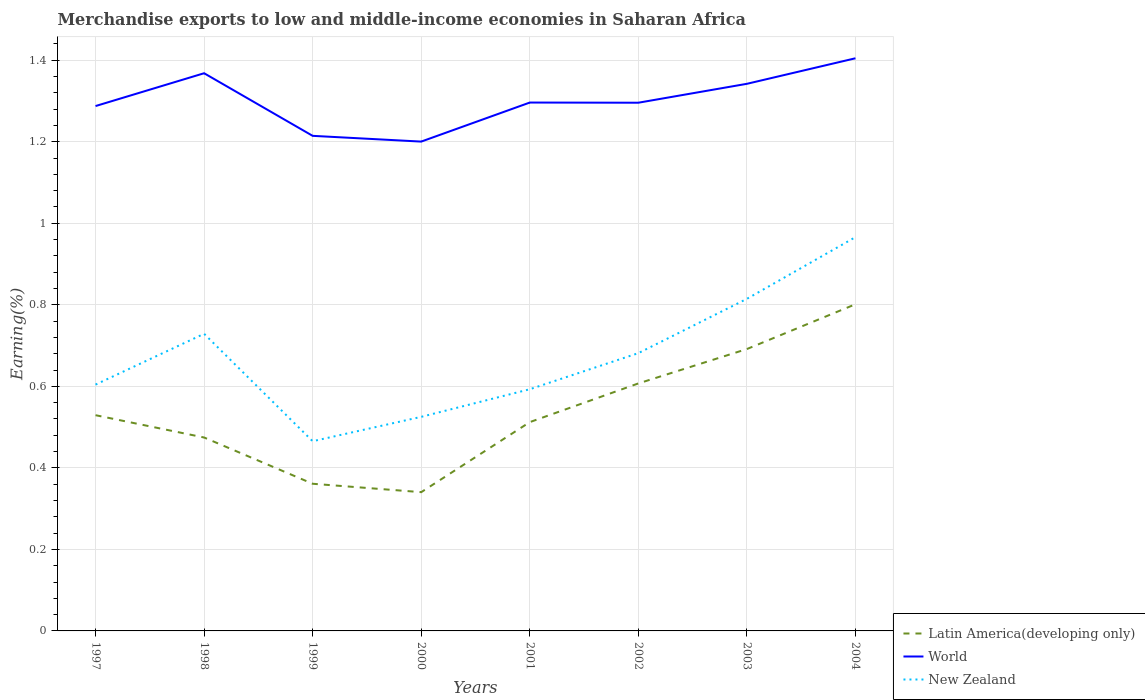How many different coloured lines are there?
Offer a very short reply. 3. Is the number of lines equal to the number of legend labels?
Provide a succinct answer. Yes. Across all years, what is the maximum percentage of amount earned from merchandise exports in New Zealand?
Your answer should be very brief. 0.47. What is the total percentage of amount earned from merchandise exports in Latin America(developing only) in the graph?
Offer a terse response. -0.08. What is the difference between the highest and the second highest percentage of amount earned from merchandise exports in Latin America(developing only)?
Keep it short and to the point. 0.46. What is the difference between two consecutive major ticks on the Y-axis?
Your answer should be compact. 0.2. Are the values on the major ticks of Y-axis written in scientific E-notation?
Ensure brevity in your answer.  No. Does the graph contain grids?
Your answer should be compact. Yes. Where does the legend appear in the graph?
Keep it short and to the point. Bottom right. What is the title of the graph?
Make the answer very short. Merchandise exports to low and middle-income economies in Saharan Africa. Does "Tonga" appear as one of the legend labels in the graph?
Your answer should be compact. No. What is the label or title of the Y-axis?
Offer a terse response. Earning(%). What is the Earning(%) of Latin America(developing only) in 1997?
Give a very brief answer. 0.53. What is the Earning(%) in World in 1997?
Give a very brief answer. 1.29. What is the Earning(%) in New Zealand in 1997?
Provide a succinct answer. 0.6. What is the Earning(%) in Latin America(developing only) in 1998?
Your answer should be very brief. 0.47. What is the Earning(%) in World in 1998?
Provide a succinct answer. 1.37. What is the Earning(%) of New Zealand in 1998?
Keep it short and to the point. 0.73. What is the Earning(%) in Latin America(developing only) in 1999?
Offer a very short reply. 0.36. What is the Earning(%) of World in 1999?
Your response must be concise. 1.21. What is the Earning(%) of New Zealand in 1999?
Make the answer very short. 0.47. What is the Earning(%) in Latin America(developing only) in 2000?
Your answer should be very brief. 0.34. What is the Earning(%) in World in 2000?
Give a very brief answer. 1.2. What is the Earning(%) in New Zealand in 2000?
Make the answer very short. 0.53. What is the Earning(%) of Latin America(developing only) in 2001?
Give a very brief answer. 0.51. What is the Earning(%) of World in 2001?
Your answer should be compact. 1.3. What is the Earning(%) in New Zealand in 2001?
Your answer should be very brief. 0.59. What is the Earning(%) of Latin America(developing only) in 2002?
Your response must be concise. 0.61. What is the Earning(%) in World in 2002?
Your response must be concise. 1.3. What is the Earning(%) in New Zealand in 2002?
Your answer should be compact. 0.68. What is the Earning(%) in Latin America(developing only) in 2003?
Keep it short and to the point. 0.69. What is the Earning(%) in World in 2003?
Your answer should be very brief. 1.34. What is the Earning(%) in New Zealand in 2003?
Offer a terse response. 0.81. What is the Earning(%) of Latin America(developing only) in 2004?
Provide a short and direct response. 0.8. What is the Earning(%) in World in 2004?
Provide a succinct answer. 1.4. What is the Earning(%) in New Zealand in 2004?
Provide a short and direct response. 0.97. Across all years, what is the maximum Earning(%) of Latin America(developing only)?
Your answer should be very brief. 0.8. Across all years, what is the maximum Earning(%) of World?
Offer a terse response. 1.4. Across all years, what is the maximum Earning(%) of New Zealand?
Make the answer very short. 0.97. Across all years, what is the minimum Earning(%) in Latin America(developing only)?
Give a very brief answer. 0.34. Across all years, what is the minimum Earning(%) in World?
Ensure brevity in your answer.  1.2. Across all years, what is the minimum Earning(%) in New Zealand?
Provide a short and direct response. 0.47. What is the total Earning(%) of Latin America(developing only) in the graph?
Offer a very short reply. 4.32. What is the total Earning(%) of World in the graph?
Provide a short and direct response. 10.41. What is the total Earning(%) of New Zealand in the graph?
Your answer should be compact. 5.38. What is the difference between the Earning(%) in Latin America(developing only) in 1997 and that in 1998?
Provide a succinct answer. 0.05. What is the difference between the Earning(%) of World in 1997 and that in 1998?
Provide a succinct answer. -0.08. What is the difference between the Earning(%) in New Zealand in 1997 and that in 1998?
Give a very brief answer. -0.12. What is the difference between the Earning(%) of Latin America(developing only) in 1997 and that in 1999?
Your response must be concise. 0.17. What is the difference between the Earning(%) in World in 1997 and that in 1999?
Ensure brevity in your answer.  0.07. What is the difference between the Earning(%) in New Zealand in 1997 and that in 1999?
Provide a succinct answer. 0.14. What is the difference between the Earning(%) in Latin America(developing only) in 1997 and that in 2000?
Keep it short and to the point. 0.19. What is the difference between the Earning(%) of World in 1997 and that in 2000?
Offer a terse response. 0.09. What is the difference between the Earning(%) in New Zealand in 1997 and that in 2000?
Offer a terse response. 0.08. What is the difference between the Earning(%) of Latin America(developing only) in 1997 and that in 2001?
Your response must be concise. 0.02. What is the difference between the Earning(%) in World in 1997 and that in 2001?
Offer a very short reply. -0.01. What is the difference between the Earning(%) in New Zealand in 1997 and that in 2001?
Provide a succinct answer. 0.01. What is the difference between the Earning(%) of Latin America(developing only) in 1997 and that in 2002?
Ensure brevity in your answer.  -0.08. What is the difference between the Earning(%) of World in 1997 and that in 2002?
Your response must be concise. -0.01. What is the difference between the Earning(%) in New Zealand in 1997 and that in 2002?
Offer a very short reply. -0.08. What is the difference between the Earning(%) of Latin America(developing only) in 1997 and that in 2003?
Offer a terse response. -0.16. What is the difference between the Earning(%) of World in 1997 and that in 2003?
Give a very brief answer. -0.05. What is the difference between the Earning(%) of New Zealand in 1997 and that in 2003?
Make the answer very short. -0.21. What is the difference between the Earning(%) in Latin America(developing only) in 1997 and that in 2004?
Your response must be concise. -0.27. What is the difference between the Earning(%) in World in 1997 and that in 2004?
Your answer should be very brief. -0.12. What is the difference between the Earning(%) of New Zealand in 1997 and that in 2004?
Provide a succinct answer. -0.36. What is the difference between the Earning(%) in Latin America(developing only) in 1998 and that in 1999?
Ensure brevity in your answer.  0.11. What is the difference between the Earning(%) in World in 1998 and that in 1999?
Provide a short and direct response. 0.15. What is the difference between the Earning(%) of New Zealand in 1998 and that in 1999?
Keep it short and to the point. 0.26. What is the difference between the Earning(%) of Latin America(developing only) in 1998 and that in 2000?
Your response must be concise. 0.13. What is the difference between the Earning(%) of World in 1998 and that in 2000?
Provide a succinct answer. 0.17. What is the difference between the Earning(%) of New Zealand in 1998 and that in 2000?
Provide a short and direct response. 0.2. What is the difference between the Earning(%) of Latin America(developing only) in 1998 and that in 2001?
Offer a very short reply. -0.04. What is the difference between the Earning(%) in World in 1998 and that in 2001?
Ensure brevity in your answer.  0.07. What is the difference between the Earning(%) of New Zealand in 1998 and that in 2001?
Your answer should be compact. 0.14. What is the difference between the Earning(%) in Latin America(developing only) in 1998 and that in 2002?
Offer a very short reply. -0.13. What is the difference between the Earning(%) in World in 1998 and that in 2002?
Give a very brief answer. 0.07. What is the difference between the Earning(%) in New Zealand in 1998 and that in 2002?
Make the answer very short. 0.05. What is the difference between the Earning(%) of Latin America(developing only) in 1998 and that in 2003?
Offer a terse response. -0.22. What is the difference between the Earning(%) in World in 1998 and that in 2003?
Keep it short and to the point. 0.03. What is the difference between the Earning(%) in New Zealand in 1998 and that in 2003?
Provide a short and direct response. -0.09. What is the difference between the Earning(%) of Latin America(developing only) in 1998 and that in 2004?
Offer a terse response. -0.33. What is the difference between the Earning(%) in World in 1998 and that in 2004?
Your answer should be compact. -0.04. What is the difference between the Earning(%) of New Zealand in 1998 and that in 2004?
Your answer should be very brief. -0.24. What is the difference between the Earning(%) in Latin America(developing only) in 1999 and that in 2000?
Your response must be concise. 0.02. What is the difference between the Earning(%) in World in 1999 and that in 2000?
Your answer should be compact. 0.01. What is the difference between the Earning(%) of New Zealand in 1999 and that in 2000?
Ensure brevity in your answer.  -0.06. What is the difference between the Earning(%) of Latin America(developing only) in 1999 and that in 2001?
Provide a succinct answer. -0.15. What is the difference between the Earning(%) in World in 1999 and that in 2001?
Your answer should be very brief. -0.08. What is the difference between the Earning(%) in New Zealand in 1999 and that in 2001?
Keep it short and to the point. -0.13. What is the difference between the Earning(%) of Latin America(developing only) in 1999 and that in 2002?
Your answer should be very brief. -0.25. What is the difference between the Earning(%) of World in 1999 and that in 2002?
Ensure brevity in your answer.  -0.08. What is the difference between the Earning(%) in New Zealand in 1999 and that in 2002?
Keep it short and to the point. -0.22. What is the difference between the Earning(%) in Latin America(developing only) in 1999 and that in 2003?
Give a very brief answer. -0.33. What is the difference between the Earning(%) of World in 1999 and that in 2003?
Your answer should be very brief. -0.13. What is the difference between the Earning(%) of New Zealand in 1999 and that in 2003?
Give a very brief answer. -0.35. What is the difference between the Earning(%) in Latin America(developing only) in 1999 and that in 2004?
Ensure brevity in your answer.  -0.44. What is the difference between the Earning(%) in World in 1999 and that in 2004?
Your answer should be compact. -0.19. What is the difference between the Earning(%) in New Zealand in 1999 and that in 2004?
Your answer should be compact. -0.5. What is the difference between the Earning(%) in Latin America(developing only) in 2000 and that in 2001?
Give a very brief answer. -0.17. What is the difference between the Earning(%) in World in 2000 and that in 2001?
Your response must be concise. -0.1. What is the difference between the Earning(%) of New Zealand in 2000 and that in 2001?
Provide a short and direct response. -0.07. What is the difference between the Earning(%) in Latin America(developing only) in 2000 and that in 2002?
Your answer should be compact. -0.27. What is the difference between the Earning(%) of World in 2000 and that in 2002?
Provide a succinct answer. -0.1. What is the difference between the Earning(%) of New Zealand in 2000 and that in 2002?
Offer a terse response. -0.16. What is the difference between the Earning(%) in Latin America(developing only) in 2000 and that in 2003?
Make the answer very short. -0.35. What is the difference between the Earning(%) of World in 2000 and that in 2003?
Offer a very short reply. -0.14. What is the difference between the Earning(%) in New Zealand in 2000 and that in 2003?
Make the answer very short. -0.29. What is the difference between the Earning(%) in Latin America(developing only) in 2000 and that in 2004?
Ensure brevity in your answer.  -0.46. What is the difference between the Earning(%) in World in 2000 and that in 2004?
Your response must be concise. -0.2. What is the difference between the Earning(%) in New Zealand in 2000 and that in 2004?
Your answer should be compact. -0.44. What is the difference between the Earning(%) in Latin America(developing only) in 2001 and that in 2002?
Make the answer very short. -0.09. What is the difference between the Earning(%) in New Zealand in 2001 and that in 2002?
Offer a terse response. -0.09. What is the difference between the Earning(%) of Latin America(developing only) in 2001 and that in 2003?
Your response must be concise. -0.18. What is the difference between the Earning(%) of World in 2001 and that in 2003?
Your answer should be very brief. -0.05. What is the difference between the Earning(%) in New Zealand in 2001 and that in 2003?
Keep it short and to the point. -0.22. What is the difference between the Earning(%) of Latin America(developing only) in 2001 and that in 2004?
Make the answer very short. -0.29. What is the difference between the Earning(%) of World in 2001 and that in 2004?
Your answer should be compact. -0.11. What is the difference between the Earning(%) of New Zealand in 2001 and that in 2004?
Provide a short and direct response. -0.37. What is the difference between the Earning(%) in Latin America(developing only) in 2002 and that in 2003?
Give a very brief answer. -0.08. What is the difference between the Earning(%) in World in 2002 and that in 2003?
Give a very brief answer. -0.05. What is the difference between the Earning(%) in New Zealand in 2002 and that in 2003?
Your answer should be compact. -0.13. What is the difference between the Earning(%) in Latin America(developing only) in 2002 and that in 2004?
Ensure brevity in your answer.  -0.19. What is the difference between the Earning(%) in World in 2002 and that in 2004?
Ensure brevity in your answer.  -0.11. What is the difference between the Earning(%) of New Zealand in 2002 and that in 2004?
Ensure brevity in your answer.  -0.28. What is the difference between the Earning(%) of Latin America(developing only) in 2003 and that in 2004?
Ensure brevity in your answer.  -0.11. What is the difference between the Earning(%) of World in 2003 and that in 2004?
Keep it short and to the point. -0.06. What is the difference between the Earning(%) in New Zealand in 2003 and that in 2004?
Offer a very short reply. -0.15. What is the difference between the Earning(%) in Latin America(developing only) in 1997 and the Earning(%) in World in 1998?
Ensure brevity in your answer.  -0.84. What is the difference between the Earning(%) of Latin America(developing only) in 1997 and the Earning(%) of New Zealand in 1998?
Ensure brevity in your answer.  -0.2. What is the difference between the Earning(%) of World in 1997 and the Earning(%) of New Zealand in 1998?
Your answer should be compact. 0.56. What is the difference between the Earning(%) of Latin America(developing only) in 1997 and the Earning(%) of World in 1999?
Give a very brief answer. -0.69. What is the difference between the Earning(%) in Latin America(developing only) in 1997 and the Earning(%) in New Zealand in 1999?
Ensure brevity in your answer.  0.06. What is the difference between the Earning(%) of World in 1997 and the Earning(%) of New Zealand in 1999?
Your answer should be very brief. 0.82. What is the difference between the Earning(%) in Latin America(developing only) in 1997 and the Earning(%) in World in 2000?
Offer a terse response. -0.67. What is the difference between the Earning(%) of Latin America(developing only) in 1997 and the Earning(%) of New Zealand in 2000?
Provide a succinct answer. 0. What is the difference between the Earning(%) of World in 1997 and the Earning(%) of New Zealand in 2000?
Your response must be concise. 0.76. What is the difference between the Earning(%) in Latin America(developing only) in 1997 and the Earning(%) in World in 2001?
Your answer should be compact. -0.77. What is the difference between the Earning(%) of Latin America(developing only) in 1997 and the Earning(%) of New Zealand in 2001?
Your response must be concise. -0.06. What is the difference between the Earning(%) of World in 1997 and the Earning(%) of New Zealand in 2001?
Provide a succinct answer. 0.69. What is the difference between the Earning(%) in Latin America(developing only) in 1997 and the Earning(%) in World in 2002?
Provide a short and direct response. -0.77. What is the difference between the Earning(%) in Latin America(developing only) in 1997 and the Earning(%) in New Zealand in 2002?
Your answer should be compact. -0.15. What is the difference between the Earning(%) in World in 1997 and the Earning(%) in New Zealand in 2002?
Offer a terse response. 0.61. What is the difference between the Earning(%) of Latin America(developing only) in 1997 and the Earning(%) of World in 2003?
Your response must be concise. -0.81. What is the difference between the Earning(%) in Latin America(developing only) in 1997 and the Earning(%) in New Zealand in 2003?
Provide a short and direct response. -0.29. What is the difference between the Earning(%) of World in 1997 and the Earning(%) of New Zealand in 2003?
Give a very brief answer. 0.47. What is the difference between the Earning(%) of Latin America(developing only) in 1997 and the Earning(%) of World in 2004?
Keep it short and to the point. -0.88. What is the difference between the Earning(%) in Latin America(developing only) in 1997 and the Earning(%) in New Zealand in 2004?
Offer a terse response. -0.44. What is the difference between the Earning(%) of World in 1997 and the Earning(%) of New Zealand in 2004?
Your answer should be compact. 0.32. What is the difference between the Earning(%) in Latin America(developing only) in 1998 and the Earning(%) in World in 1999?
Offer a very short reply. -0.74. What is the difference between the Earning(%) of Latin America(developing only) in 1998 and the Earning(%) of New Zealand in 1999?
Provide a short and direct response. 0.01. What is the difference between the Earning(%) of World in 1998 and the Earning(%) of New Zealand in 1999?
Provide a short and direct response. 0.9. What is the difference between the Earning(%) of Latin America(developing only) in 1998 and the Earning(%) of World in 2000?
Keep it short and to the point. -0.73. What is the difference between the Earning(%) in Latin America(developing only) in 1998 and the Earning(%) in New Zealand in 2000?
Offer a very short reply. -0.05. What is the difference between the Earning(%) in World in 1998 and the Earning(%) in New Zealand in 2000?
Keep it short and to the point. 0.84. What is the difference between the Earning(%) of Latin America(developing only) in 1998 and the Earning(%) of World in 2001?
Offer a terse response. -0.82. What is the difference between the Earning(%) in Latin America(developing only) in 1998 and the Earning(%) in New Zealand in 2001?
Keep it short and to the point. -0.12. What is the difference between the Earning(%) of World in 1998 and the Earning(%) of New Zealand in 2001?
Offer a very short reply. 0.78. What is the difference between the Earning(%) of Latin America(developing only) in 1998 and the Earning(%) of World in 2002?
Offer a very short reply. -0.82. What is the difference between the Earning(%) in Latin America(developing only) in 1998 and the Earning(%) in New Zealand in 2002?
Your answer should be very brief. -0.21. What is the difference between the Earning(%) in World in 1998 and the Earning(%) in New Zealand in 2002?
Offer a terse response. 0.69. What is the difference between the Earning(%) in Latin America(developing only) in 1998 and the Earning(%) in World in 2003?
Your response must be concise. -0.87. What is the difference between the Earning(%) in Latin America(developing only) in 1998 and the Earning(%) in New Zealand in 2003?
Your answer should be very brief. -0.34. What is the difference between the Earning(%) in World in 1998 and the Earning(%) in New Zealand in 2003?
Offer a terse response. 0.55. What is the difference between the Earning(%) in Latin America(developing only) in 1998 and the Earning(%) in World in 2004?
Provide a succinct answer. -0.93. What is the difference between the Earning(%) in Latin America(developing only) in 1998 and the Earning(%) in New Zealand in 2004?
Offer a terse response. -0.49. What is the difference between the Earning(%) in World in 1998 and the Earning(%) in New Zealand in 2004?
Offer a terse response. 0.4. What is the difference between the Earning(%) of Latin America(developing only) in 1999 and the Earning(%) of World in 2000?
Offer a terse response. -0.84. What is the difference between the Earning(%) in Latin America(developing only) in 1999 and the Earning(%) in New Zealand in 2000?
Provide a short and direct response. -0.16. What is the difference between the Earning(%) of World in 1999 and the Earning(%) of New Zealand in 2000?
Offer a terse response. 0.69. What is the difference between the Earning(%) of Latin America(developing only) in 1999 and the Earning(%) of World in 2001?
Your answer should be compact. -0.94. What is the difference between the Earning(%) of Latin America(developing only) in 1999 and the Earning(%) of New Zealand in 2001?
Keep it short and to the point. -0.23. What is the difference between the Earning(%) in World in 1999 and the Earning(%) in New Zealand in 2001?
Offer a terse response. 0.62. What is the difference between the Earning(%) in Latin America(developing only) in 1999 and the Earning(%) in World in 2002?
Ensure brevity in your answer.  -0.93. What is the difference between the Earning(%) of Latin America(developing only) in 1999 and the Earning(%) of New Zealand in 2002?
Ensure brevity in your answer.  -0.32. What is the difference between the Earning(%) of World in 1999 and the Earning(%) of New Zealand in 2002?
Make the answer very short. 0.53. What is the difference between the Earning(%) in Latin America(developing only) in 1999 and the Earning(%) in World in 2003?
Make the answer very short. -0.98. What is the difference between the Earning(%) in Latin America(developing only) in 1999 and the Earning(%) in New Zealand in 2003?
Offer a very short reply. -0.45. What is the difference between the Earning(%) in World in 1999 and the Earning(%) in New Zealand in 2003?
Provide a short and direct response. 0.4. What is the difference between the Earning(%) of Latin America(developing only) in 1999 and the Earning(%) of World in 2004?
Your answer should be very brief. -1.04. What is the difference between the Earning(%) in Latin America(developing only) in 1999 and the Earning(%) in New Zealand in 2004?
Provide a short and direct response. -0.6. What is the difference between the Earning(%) of World in 1999 and the Earning(%) of New Zealand in 2004?
Keep it short and to the point. 0.25. What is the difference between the Earning(%) in Latin America(developing only) in 2000 and the Earning(%) in World in 2001?
Provide a succinct answer. -0.96. What is the difference between the Earning(%) of Latin America(developing only) in 2000 and the Earning(%) of New Zealand in 2001?
Ensure brevity in your answer.  -0.25. What is the difference between the Earning(%) in World in 2000 and the Earning(%) in New Zealand in 2001?
Make the answer very short. 0.61. What is the difference between the Earning(%) of Latin America(developing only) in 2000 and the Earning(%) of World in 2002?
Your answer should be compact. -0.96. What is the difference between the Earning(%) in Latin America(developing only) in 2000 and the Earning(%) in New Zealand in 2002?
Your answer should be compact. -0.34. What is the difference between the Earning(%) in World in 2000 and the Earning(%) in New Zealand in 2002?
Keep it short and to the point. 0.52. What is the difference between the Earning(%) in Latin America(developing only) in 2000 and the Earning(%) in World in 2003?
Give a very brief answer. -1. What is the difference between the Earning(%) of Latin America(developing only) in 2000 and the Earning(%) of New Zealand in 2003?
Your answer should be very brief. -0.47. What is the difference between the Earning(%) in World in 2000 and the Earning(%) in New Zealand in 2003?
Make the answer very short. 0.39. What is the difference between the Earning(%) in Latin America(developing only) in 2000 and the Earning(%) in World in 2004?
Give a very brief answer. -1.06. What is the difference between the Earning(%) in Latin America(developing only) in 2000 and the Earning(%) in New Zealand in 2004?
Provide a succinct answer. -0.63. What is the difference between the Earning(%) in World in 2000 and the Earning(%) in New Zealand in 2004?
Provide a short and direct response. 0.23. What is the difference between the Earning(%) in Latin America(developing only) in 2001 and the Earning(%) in World in 2002?
Offer a terse response. -0.78. What is the difference between the Earning(%) of Latin America(developing only) in 2001 and the Earning(%) of New Zealand in 2002?
Keep it short and to the point. -0.17. What is the difference between the Earning(%) of World in 2001 and the Earning(%) of New Zealand in 2002?
Give a very brief answer. 0.61. What is the difference between the Earning(%) in Latin America(developing only) in 2001 and the Earning(%) in World in 2003?
Give a very brief answer. -0.83. What is the difference between the Earning(%) in Latin America(developing only) in 2001 and the Earning(%) in New Zealand in 2003?
Give a very brief answer. -0.3. What is the difference between the Earning(%) of World in 2001 and the Earning(%) of New Zealand in 2003?
Your answer should be compact. 0.48. What is the difference between the Earning(%) of Latin America(developing only) in 2001 and the Earning(%) of World in 2004?
Your answer should be very brief. -0.89. What is the difference between the Earning(%) of Latin America(developing only) in 2001 and the Earning(%) of New Zealand in 2004?
Your response must be concise. -0.45. What is the difference between the Earning(%) of World in 2001 and the Earning(%) of New Zealand in 2004?
Provide a succinct answer. 0.33. What is the difference between the Earning(%) of Latin America(developing only) in 2002 and the Earning(%) of World in 2003?
Provide a succinct answer. -0.74. What is the difference between the Earning(%) of Latin America(developing only) in 2002 and the Earning(%) of New Zealand in 2003?
Your answer should be very brief. -0.21. What is the difference between the Earning(%) of World in 2002 and the Earning(%) of New Zealand in 2003?
Ensure brevity in your answer.  0.48. What is the difference between the Earning(%) of Latin America(developing only) in 2002 and the Earning(%) of World in 2004?
Make the answer very short. -0.8. What is the difference between the Earning(%) of Latin America(developing only) in 2002 and the Earning(%) of New Zealand in 2004?
Your answer should be compact. -0.36. What is the difference between the Earning(%) in World in 2002 and the Earning(%) in New Zealand in 2004?
Provide a succinct answer. 0.33. What is the difference between the Earning(%) in Latin America(developing only) in 2003 and the Earning(%) in World in 2004?
Keep it short and to the point. -0.71. What is the difference between the Earning(%) in Latin America(developing only) in 2003 and the Earning(%) in New Zealand in 2004?
Your answer should be very brief. -0.27. What is the difference between the Earning(%) of World in 2003 and the Earning(%) of New Zealand in 2004?
Offer a very short reply. 0.38. What is the average Earning(%) in Latin America(developing only) per year?
Ensure brevity in your answer.  0.54. What is the average Earning(%) in World per year?
Give a very brief answer. 1.3. What is the average Earning(%) of New Zealand per year?
Keep it short and to the point. 0.67. In the year 1997, what is the difference between the Earning(%) of Latin America(developing only) and Earning(%) of World?
Your response must be concise. -0.76. In the year 1997, what is the difference between the Earning(%) in Latin America(developing only) and Earning(%) in New Zealand?
Your answer should be compact. -0.08. In the year 1997, what is the difference between the Earning(%) in World and Earning(%) in New Zealand?
Provide a succinct answer. 0.68. In the year 1998, what is the difference between the Earning(%) of Latin America(developing only) and Earning(%) of World?
Keep it short and to the point. -0.89. In the year 1998, what is the difference between the Earning(%) of Latin America(developing only) and Earning(%) of New Zealand?
Make the answer very short. -0.25. In the year 1998, what is the difference between the Earning(%) in World and Earning(%) in New Zealand?
Keep it short and to the point. 0.64. In the year 1999, what is the difference between the Earning(%) in Latin America(developing only) and Earning(%) in World?
Provide a short and direct response. -0.85. In the year 1999, what is the difference between the Earning(%) of Latin America(developing only) and Earning(%) of New Zealand?
Make the answer very short. -0.1. In the year 1999, what is the difference between the Earning(%) in World and Earning(%) in New Zealand?
Your response must be concise. 0.75. In the year 2000, what is the difference between the Earning(%) in Latin America(developing only) and Earning(%) in World?
Ensure brevity in your answer.  -0.86. In the year 2000, what is the difference between the Earning(%) in Latin America(developing only) and Earning(%) in New Zealand?
Your answer should be compact. -0.18. In the year 2000, what is the difference between the Earning(%) of World and Earning(%) of New Zealand?
Your response must be concise. 0.68. In the year 2001, what is the difference between the Earning(%) of Latin America(developing only) and Earning(%) of World?
Your response must be concise. -0.78. In the year 2001, what is the difference between the Earning(%) of Latin America(developing only) and Earning(%) of New Zealand?
Offer a very short reply. -0.08. In the year 2001, what is the difference between the Earning(%) in World and Earning(%) in New Zealand?
Provide a short and direct response. 0.7. In the year 2002, what is the difference between the Earning(%) of Latin America(developing only) and Earning(%) of World?
Give a very brief answer. -0.69. In the year 2002, what is the difference between the Earning(%) in Latin America(developing only) and Earning(%) in New Zealand?
Your answer should be very brief. -0.07. In the year 2002, what is the difference between the Earning(%) in World and Earning(%) in New Zealand?
Provide a short and direct response. 0.61. In the year 2003, what is the difference between the Earning(%) of Latin America(developing only) and Earning(%) of World?
Your answer should be compact. -0.65. In the year 2003, what is the difference between the Earning(%) of Latin America(developing only) and Earning(%) of New Zealand?
Provide a short and direct response. -0.12. In the year 2003, what is the difference between the Earning(%) of World and Earning(%) of New Zealand?
Your response must be concise. 0.53. In the year 2004, what is the difference between the Earning(%) of Latin America(developing only) and Earning(%) of World?
Your answer should be very brief. -0.6. In the year 2004, what is the difference between the Earning(%) in Latin America(developing only) and Earning(%) in New Zealand?
Make the answer very short. -0.16. In the year 2004, what is the difference between the Earning(%) in World and Earning(%) in New Zealand?
Your answer should be compact. 0.44. What is the ratio of the Earning(%) in Latin America(developing only) in 1997 to that in 1998?
Your response must be concise. 1.12. What is the ratio of the Earning(%) in World in 1997 to that in 1998?
Give a very brief answer. 0.94. What is the ratio of the Earning(%) in New Zealand in 1997 to that in 1998?
Offer a very short reply. 0.83. What is the ratio of the Earning(%) in Latin America(developing only) in 1997 to that in 1999?
Provide a succinct answer. 1.47. What is the ratio of the Earning(%) in World in 1997 to that in 1999?
Your response must be concise. 1.06. What is the ratio of the Earning(%) of New Zealand in 1997 to that in 1999?
Make the answer very short. 1.3. What is the ratio of the Earning(%) of Latin America(developing only) in 1997 to that in 2000?
Give a very brief answer. 1.55. What is the ratio of the Earning(%) of World in 1997 to that in 2000?
Give a very brief answer. 1.07. What is the ratio of the Earning(%) in New Zealand in 1997 to that in 2000?
Your answer should be very brief. 1.15. What is the ratio of the Earning(%) in Latin America(developing only) in 1997 to that in 2001?
Give a very brief answer. 1.03. What is the ratio of the Earning(%) of New Zealand in 1997 to that in 2001?
Keep it short and to the point. 1.02. What is the ratio of the Earning(%) of Latin America(developing only) in 1997 to that in 2002?
Provide a succinct answer. 0.87. What is the ratio of the Earning(%) in New Zealand in 1997 to that in 2002?
Give a very brief answer. 0.89. What is the ratio of the Earning(%) in Latin America(developing only) in 1997 to that in 2003?
Keep it short and to the point. 0.77. What is the ratio of the Earning(%) in World in 1997 to that in 2003?
Offer a very short reply. 0.96. What is the ratio of the Earning(%) of New Zealand in 1997 to that in 2003?
Your response must be concise. 0.74. What is the ratio of the Earning(%) in Latin America(developing only) in 1997 to that in 2004?
Ensure brevity in your answer.  0.66. What is the ratio of the Earning(%) in World in 1997 to that in 2004?
Offer a terse response. 0.92. What is the ratio of the Earning(%) of New Zealand in 1997 to that in 2004?
Give a very brief answer. 0.63. What is the ratio of the Earning(%) of Latin America(developing only) in 1998 to that in 1999?
Give a very brief answer. 1.31. What is the ratio of the Earning(%) of World in 1998 to that in 1999?
Make the answer very short. 1.13. What is the ratio of the Earning(%) in New Zealand in 1998 to that in 1999?
Offer a very short reply. 1.57. What is the ratio of the Earning(%) of Latin America(developing only) in 1998 to that in 2000?
Ensure brevity in your answer.  1.39. What is the ratio of the Earning(%) of World in 1998 to that in 2000?
Your response must be concise. 1.14. What is the ratio of the Earning(%) of New Zealand in 1998 to that in 2000?
Offer a very short reply. 1.39. What is the ratio of the Earning(%) of Latin America(developing only) in 1998 to that in 2001?
Offer a terse response. 0.93. What is the ratio of the Earning(%) in World in 1998 to that in 2001?
Provide a succinct answer. 1.06. What is the ratio of the Earning(%) in New Zealand in 1998 to that in 2001?
Offer a terse response. 1.23. What is the ratio of the Earning(%) of Latin America(developing only) in 1998 to that in 2002?
Offer a very short reply. 0.78. What is the ratio of the Earning(%) of World in 1998 to that in 2002?
Make the answer very short. 1.06. What is the ratio of the Earning(%) in New Zealand in 1998 to that in 2002?
Your answer should be compact. 1.07. What is the ratio of the Earning(%) of Latin America(developing only) in 1998 to that in 2003?
Your answer should be very brief. 0.69. What is the ratio of the Earning(%) in World in 1998 to that in 2003?
Give a very brief answer. 1.02. What is the ratio of the Earning(%) of New Zealand in 1998 to that in 2003?
Your answer should be very brief. 0.89. What is the ratio of the Earning(%) in Latin America(developing only) in 1998 to that in 2004?
Offer a terse response. 0.59. What is the ratio of the Earning(%) in World in 1998 to that in 2004?
Your answer should be compact. 0.97. What is the ratio of the Earning(%) of New Zealand in 1998 to that in 2004?
Offer a terse response. 0.75. What is the ratio of the Earning(%) in Latin America(developing only) in 1999 to that in 2000?
Give a very brief answer. 1.06. What is the ratio of the Earning(%) in World in 1999 to that in 2000?
Offer a very short reply. 1.01. What is the ratio of the Earning(%) of New Zealand in 1999 to that in 2000?
Ensure brevity in your answer.  0.89. What is the ratio of the Earning(%) in Latin America(developing only) in 1999 to that in 2001?
Offer a very short reply. 0.7. What is the ratio of the Earning(%) of World in 1999 to that in 2001?
Provide a short and direct response. 0.94. What is the ratio of the Earning(%) in New Zealand in 1999 to that in 2001?
Provide a succinct answer. 0.78. What is the ratio of the Earning(%) in Latin America(developing only) in 1999 to that in 2002?
Keep it short and to the point. 0.59. What is the ratio of the Earning(%) of World in 1999 to that in 2002?
Your answer should be compact. 0.94. What is the ratio of the Earning(%) of New Zealand in 1999 to that in 2002?
Your answer should be very brief. 0.68. What is the ratio of the Earning(%) in Latin America(developing only) in 1999 to that in 2003?
Offer a terse response. 0.52. What is the ratio of the Earning(%) in World in 1999 to that in 2003?
Your response must be concise. 0.9. What is the ratio of the Earning(%) of New Zealand in 1999 to that in 2003?
Give a very brief answer. 0.57. What is the ratio of the Earning(%) in Latin America(developing only) in 1999 to that in 2004?
Your answer should be very brief. 0.45. What is the ratio of the Earning(%) in World in 1999 to that in 2004?
Keep it short and to the point. 0.86. What is the ratio of the Earning(%) in New Zealand in 1999 to that in 2004?
Ensure brevity in your answer.  0.48. What is the ratio of the Earning(%) of Latin America(developing only) in 2000 to that in 2001?
Ensure brevity in your answer.  0.66. What is the ratio of the Earning(%) of World in 2000 to that in 2001?
Your answer should be very brief. 0.93. What is the ratio of the Earning(%) of New Zealand in 2000 to that in 2001?
Provide a short and direct response. 0.89. What is the ratio of the Earning(%) in Latin America(developing only) in 2000 to that in 2002?
Your answer should be compact. 0.56. What is the ratio of the Earning(%) of World in 2000 to that in 2002?
Keep it short and to the point. 0.93. What is the ratio of the Earning(%) of New Zealand in 2000 to that in 2002?
Provide a short and direct response. 0.77. What is the ratio of the Earning(%) of Latin America(developing only) in 2000 to that in 2003?
Keep it short and to the point. 0.49. What is the ratio of the Earning(%) of World in 2000 to that in 2003?
Make the answer very short. 0.89. What is the ratio of the Earning(%) in New Zealand in 2000 to that in 2003?
Provide a short and direct response. 0.64. What is the ratio of the Earning(%) of Latin America(developing only) in 2000 to that in 2004?
Give a very brief answer. 0.42. What is the ratio of the Earning(%) of World in 2000 to that in 2004?
Keep it short and to the point. 0.85. What is the ratio of the Earning(%) in New Zealand in 2000 to that in 2004?
Your response must be concise. 0.54. What is the ratio of the Earning(%) of Latin America(developing only) in 2001 to that in 2002?
Your answer should be very brief. 0.84. What is the ratio of the Earning(%) in World in 2001 to that in 2002?
Ensure brevity in your answer.  1. What is the ratio of the Earning(%) in New Zealand in 2001 to that in 2002?
Keep it short and to the point. 0.87. What is the ratio of the Earning(%) of Latin America(developing only) in 2001 to that in 2003?
Ensure brevity in your answer.  0.74. What is the ratio of the Earning(%) in World in 2001 to that in 2003?
Provide a short and direct response. 0.97. What is the ratio of the Earning(%) in New Zealand in 2001 to that in 2003?
Your answer should be compact. 0.73. What is the ratio of the Earning(%) of Latin America(developing only) in 2001 to that in 2004?
Give a very brief answer. 0.64. What is the ratio of the Earning(%) of World in 2001 to that in 2004?
Keep it short and to the point. 0.92. What is the ratio of the Earning(%) in New Zealand in 2001 to that in 2004?
Give a very brief answer. 0.61. What is the ratio of the Earning(%) in Latin America(developing only) in 2002 to that in 2003?
Provide a succinct answer. 0.88. What is the ratio of the Earning(%) of World in 2002 to that in 2003?
Your answer should be compact. 0.97. What is the ratio of the Earning(%) in New Zealand in 2002 to that in 2003?
Provide a short and direct response. 0.84. What is the ratio of the Earning(%) of Latin America(developing only) in 2002 to that in 2004?
Give a very brief answer. 0.76. What is the ratio of the Earning(%) of World in 2002 to that in 2004?
Give a very brief answer. 0.92. What is the ratio of the Earning(%) of New Zealand in 2002 to that in 2004?
Offer a terse response. 0.71. What is the ratio of the Earning(%) of Latin America(developing only) in 2003 to that in 2004?
Your answer should be compact. 0.86. What is the ratio of the Earning(%) in World in 2003 to that in 2004?
Provide a short and direct response. 0.96. What is the ratio of the Earning(%) of New Zealand in 2003 to that in 2004?
Provide a short and direct response. 0.84. What is the difference between the highest and the second highest Earning(%) of Latin America(developing only)?
Give a very brief answer. 0.11. What is the difference between the highest and the second highest Earning(%) in World?
Keep it short and to the point. 0.04. What is the difference between the highest and the second highest Earning(%) in New Zealand?
Keep it short and to the point. 0.15. What is the difference between the highest and the lowest Earning(%) of Latin America(developing only)?
Give a very brief answer. 0.46. What is the difference between the highest and the lowest Earning(%) in World?
Offer a terse response. 0.2. What is the difference between the highest and the lowest Earning(%) in New Zealand?
Keep it short and to the point. 0.5. 